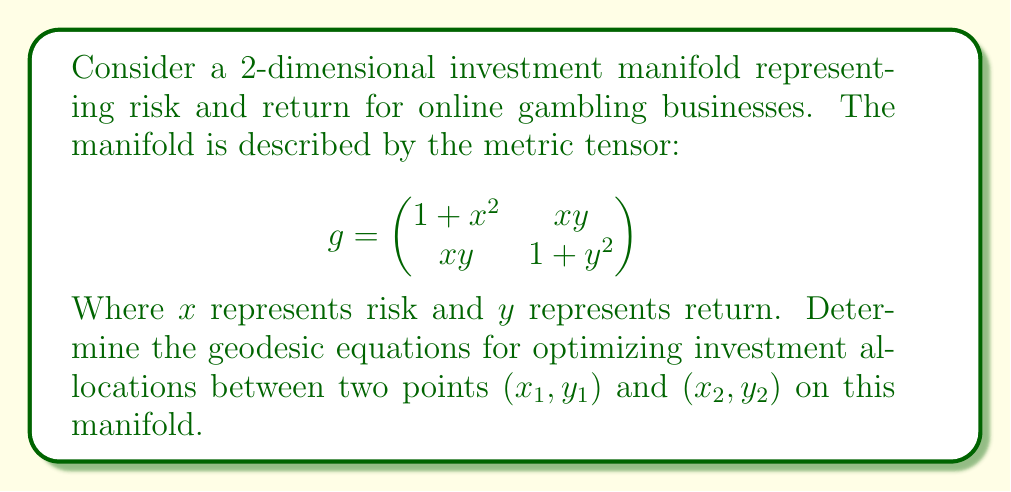Provide a solution to this math problem. To find the geodesic equations, we'll follow these steps:

1. Calculate the Christoffel symbols:
   The Christoffel symbols are given by:
   $$\Gamma_{ij}^k = \frac{1}{2}g^{kl}(\partial_i g_{jl} + \partial_j g_{il} - \partial_l g_{ij})$$

   First, we need to find the inverse metric tensor:
   $$g^{-1} = \frac{1}{(1+x^2)(1+y^2)-x^2y^2}\begin{pmatrix}
   1+y^2 & -xy \\
   -xy & 1+x^2
   \end{pmatrix}$$

   Now, we can calculate the Christoffel symbols:
   $$\Gamma_{11}^1 = \frac{x(1+y^2)}{(1+x^2)(1+y^2)-x^2y^2}$$
   $$\Gamma_{12}^1 = \Gamma_{21}^1 = \frac{y(1+y^2)}{(1+x^2)(1+y^2)-x^2y^2}$$
   $$\Gamma_{22}^1 = \frac{-xy}{(1+x^2)(1+y^2)-x^2y^2}$$
   $$\Gamma_{11}^2 = \frac{-xy}{(1+x^2)(1+y^2)-x^2y^2}$$
   $$\Gamma_{12}^2 = \Gamma_{21}^2 = \frac{x(1+x^2)}{(1+x^2)(1+y^2)-x^2y^2}$$
   $$\Gamma_{22}^2 = \frac{y(1+x^2)}{(1+x^2)(1+y^2)-x^2y^2}$$

2. Write the geodesic equations:
   The geodesic equations are:
   $$\frac{d^2x^i}{dt^2} + \Gamma_{jk}^i\frac{dx^j}{dt}\frac{dx^k}{dt} = 0$$

   For our 2-dimensional manifold, this gives us two equations:
   
   $$\frac{d^2x}{dt^2} + \Gamma_{11}^1\left(\frac{dx}{dt}\right)^2 + 2\Gamma_{12}^1\frac{dx}{dt}\frac{dy}{dt} + \Gamma_{22}^1\left(\frac{dy}{dt}\right)^2 = 0$$
   
   $$\frac{d^2y}{dt^2} + \Gamma_{11}^2\left(\frac{dx}{dt}\right)^2 + 2\Gamma_{12}^2\frac{dx}{dt}\frac{dy}{dt} + \Gamma_{22}^2\left(\frac{dy}{dt}\right)^2 = 0$$

3. Substitute the Christoffel symbols:
   
   $$\frac{d^2x}{dt^2} + \frac{x(1+y^2)}{(1+x^2)(1+y^2)-x^2y^2}\left(\frac{dx}{dt}\right)^2 + \frac{2y(1+y^2)}{(1+x^2)(1+y^2)-x^2y^2}\frac{dx}{dt}\frac{dy}{dt} - \frac{xy}{(1+x^2)(1+y^2)-x^2y^2}\left(\frac{dy}{dt}\right)^2 = 0$$
   
   $$\frac{d^2y}{dt^2} - \frac{xy}{(1+x^2)(1+y^2)-x^2y^2}\left(\frac{dx}{dt}\right)^2 + \frac{2x(1+x^2)}{(1+x^2)(1+y^2)-x^2y^2}\frac{dx}{dt}\frac{dy}{dt} + \frac{y(1+x^2)}{(1+x^2)(1+y^2)-x^2y^2}\left(\frac{dy}{dt}\right)^2 = 0$$

These are the geodesic equations for optimizing investment allocations on the given manifold.
Answer: $$\begin{cases}
\frac{d^2x}{dt^2} + \frac{x(1+y^2)}{(1+x^2)(1+y^2)-x^2y^2}\left(\frac{dx}{dt}\right)^2 + \frac{2y(1+y^2)}{(1+x^2)(1+y^2)-x^2y^2}\frac{dx}{dt}\frac{dy}{dt} - \frac{xy}{(1+x^2)(1+y^2)-x^2y^2}\left(\frac{dy}{dt}\right)^2 = 0 \\
\frac{d^2y}{dt^2} - \frac{xy}{(1+x^2)(1+y^2)-x^2y^2}\left(\frac{dx}{dt}\right)^2 + \frac{2x(1+x^2)}{(1+x^2)(1+y^2)-x^2y^2}\frac{dx}{dt}\frac{dy}{dt} + \frac{y(1+x^2)}{(1+x^2)(1+y^2)-x^2y^2}\left(\frac{dy}{dt}\right)^2 = 0
\end{cases}$$ 